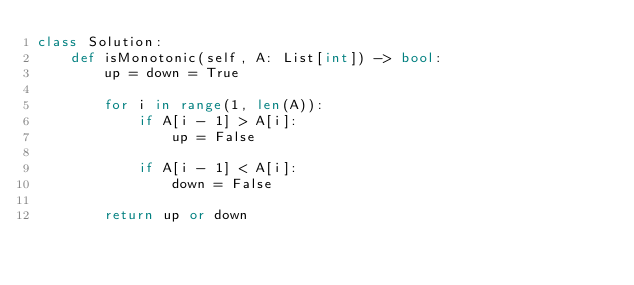Convert code to text. <code><loc_0><loc_0><loc_500><loc_500><_Python_>class Solution:
    def isMonotonic(self, A: List[int]) -> bool:
        up = down = True
        
        for i in range(1, len(A)):
            if A[i - 1] > A[i]:
                up = False

            if A[i - 1] < A[i]:
                down = False
        
        return up or down</code> 